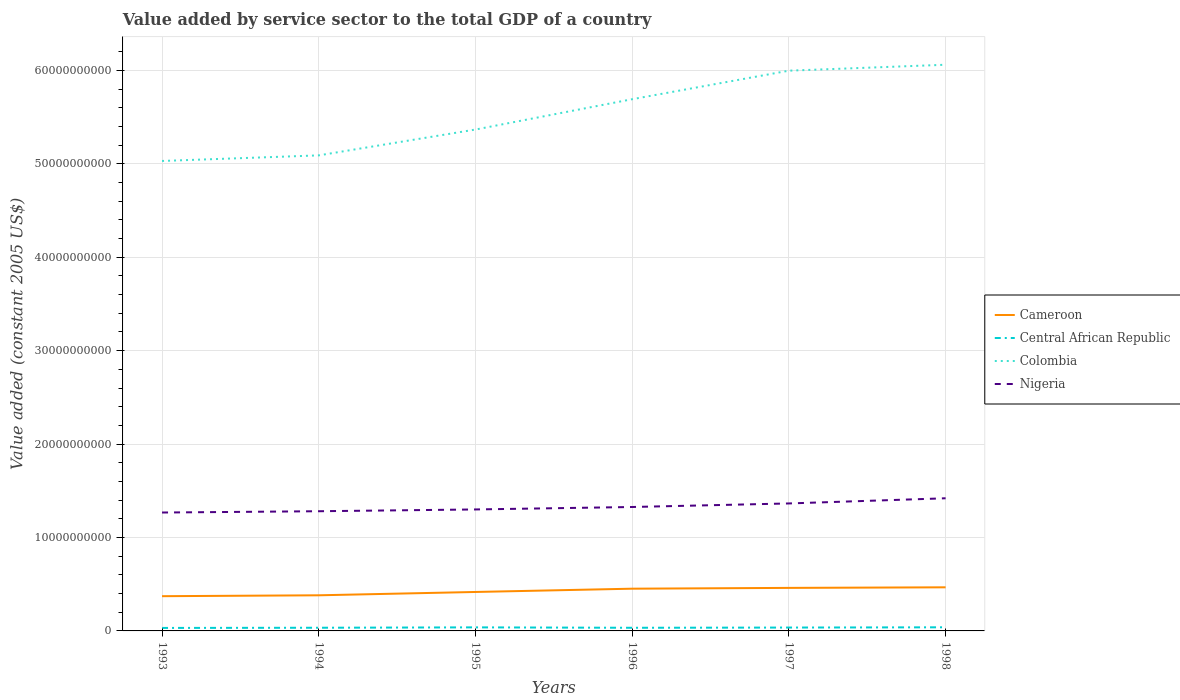How many different coloured lines are there?
Your answer should be compact. 4. Does the line corresponding to Nigeria intersect with the line corresponding to Colombia?
Provide a short and direct response. No. Across all years, what is the maximum value added by service sector in Cameroon?
Offer a terse response. 3.72e+09. In which year was the value added by service sector in Central African Republic maximum?
Make the answer very short. 1993. What is the total value added by service sector in Central African Republic in the graph?
Give a very brief answer. -4.06e+07. What is the difference between the highest and the second highest value added by service sector in Cameroon?
Make the answer very short. 9.51e+08. What is the difference between the highest and the lowest value added by service sector in Cameroon?
Your response must be concise. 3. Is the value added by service sector in Central African Republic strictly greater than the value added by service sector in Colombia over the years?
Your answer should be compact. Yes. How many lines are there?
Offer a terse response. 4. Does the graph contain any zero values?
Offer a very short reply. No. Where does the legend appear in the graph?
Your answer should be very brief. Center right. How are the legend labels stacked?
Offer a very short reply. Vertical. What is the title of the graph?
Your answer should be very brief. Value added by service sector to the total GDP of a country. What is the label or title of the X-axis?
Make the answer very short. Years. What is the label or title of the Y-axis?
Make the answer very short. Value added (constant 2005 US$). What is the Value added (constant 2005 US$) of Cameroon in 1993?
Your response must be concise. 3.72e+09. What is the Value added (constant 2005 US$) in Central African Republic in 1993?
Make the answer very short. 3.20e+08. What is the Value added (constant 2005 US$) in Colombia in 1993?
Provide a succinct answer. 5.03e+1. What is the Value added (constant 2005 US$) in Nigeria in 1993?
Give a very brief answer. 1.27e+1. What is the Value added (constant 2005 US$) of Cameroon in 1994?
Your answer should be compact. 3.81e+09. What is the Value added (constant 2005 US$) of Central African Republic in 1994?
Give a very brief answer. 3.40e+08. What is the Value added (constant 2005 US$) in Colombia in 1994?
Offer a terse response. 5.09e+1. What is the Value added (constant 2005 US$) of Nigeria in 1994?
Your answer should be very brief. 1.28e+1. What is the Value added (constant 2005 US$) in Cameroon in 1995?
Your response must be concise. 4.17e+09. What is the Value added (constant 2005 US$) in Central African Republic in 1995?
Offer a very short reply. 3.81e+08. What is the Value added (constant 2005 US$) in Colombia in 1995?
Ensure brevity in your answer.  5.37e+1. What is the Value added (constant 2005 US$) in Nigeria in 1995?
Offer a terse response. 1.30e+1. What is the Value added (constant 2005 US$) of Cameroon in 1996?
Offer a very short reply. 4.52e+09. What is the Value added (constant 2005 US$) in Central African Republic in 1996?
Give a very brief answer. 3.36e+08. What is the Value added (constant 2005 US$) of Colombia in 1996?
Keep it short and to the point. 5.69e+1. What is the Value added (constant 2005 US$) of Nigeria in 1996?
Offer a very short reply. 1.33e+1. What is the Value added (constant 2005 US$) of Cameroon in 1997?
Provide a short and direct response. 4.61e+09. What is the Value added (constant 2005 US$) in Central African Republic in 1997?
Offer a terse response. 3.60e+08. What is the Value added (constant 2005 US$) in Colombia in 1997?
Keep it short and to the point. 6.00e+1. What is the Value added (constant 2005 US$) in Nigeria in 1997?
Offer a terse response. 1.36e+1. What is the Value added (constant 2005 US$) of Cameroon in 1998?
Keep it short and to the point. 4.67e+09. What is the Value added (constant 2005 US$) in Central African Republic in 1998?
Provide a succinct answer. 3.87e+08. What is the Value added (constant 2005 US$) of Colombia in 1998?
Make the answer very short. 6.06e+1. What is the Value added (constant 2005 US$) in Nigeria in 1998?
Your response must be concise. 1.42e+1. Across all years, what is the maximum Value added (constant 2005 US$) of Cameroon?
Make the answer very short. 4.67e+09. Across all years, what is the maximum Value added (constant 2005 US$) of Central African Republic?
Offer a terse response. 3.87e+08. Across all years, what is the maximum Value added (constant 2005 US$) in Colombia?
Your answer should be very brief. 6.06e+1. Across all years, what is the maximum Value added (constant 2005 US$) in Nigeria?
Give a very brief answer. 1.42e+1. Across all years, what is the minimum Value added (constant 2005 US$) in Cameroon?
Your answer should be very brief. 3.72e+09. Across all years, what is the minimum Value added (constant 2005 US$) of Central African Republic?
Your answer should be compact. 3.20e+08. Across all years, what is the minimum Value added (constant 2005 US$) in Colombia?
Your answer should be very brief. 5.03e+1. Across all years, what is the minimum Value added (constant 2005 US$) in Nigeria?
Make the answer very short. 1.27e+1. What is the total Value added (constant 2005 US$) in Cameroon in the graph?
Offer a very short reply. 2.55e+1. What is the total Value added (constant 2005 US$) of Central African Republic in the graph?
Offer a very short reply. 2.12e+09. What is the total Value added (constant 2005 US$) in Colombia in the graph?
Your response must be concise. 3.32e+11. What is the total Value added (constant 2005 US$) in Nigeria in the graph?
Make the answer very short. 7.96e+1. What is the difference between the Value added (constant 2005 US$) of Cameroon in 1993 and that in 1994?
Ensure brevity in your answer.  -9.64e+07. What is the difference between the Value added (constant 2005 US$) in Central African Republic in 1993 and that in 1994?
Offer a terse response. -2.01e+07. What is the difference between the Value added (constant 2005 US$) in Colombia in 1993 and that in 1994?
Ensure brevity in your answer.  -5.99e+08. What is the difference between the Value added (constant 2005 US$) of Nigeria in 1993 and that in 1994?
Ensure brevity in your answer.  -1.39e+08. What is the difference between the Value added (constant 2005 US$) of Cameroon in 1993 and that in 1995?
Provide a succinct answer. -4.52e+08. What is the difference between the Value added (constant 2005 US$) of Central African Republic in 1993 and that in 1995?
Your answer should be compact. -6.07e+07. What is the difference between the Value added (constant 2005 US$) in Colombia in 1993 and that in 1995?
Provide a succinct answer. -3.36e+09. What is the difference between the Value added (constant 2005 US$) of Nigeria in 1993 and that in 1995?
Make the answer very short. -3.29e+08. What is the difference between the Value added (constant 2005 US$) in Cameroon in 1993 and that in 1996?
Your response must be concise. -8.04e+08. What is the difference between the Value added (constant 2005 US$) in Central African Republic in 1993 and that in 1996?
Provide a succinct answer. -1.63e+07. What is the difference between the Value added (constant 2005 US$) in Colombia in 1993 and that in 1996?
Your answer should be very brief. -6.61e+09. What is the difference between the Value added (constant 2005 US$) of Nigeria in 1993 and that in 1996?
Your answer should be very brief. -5.92e+08. What is the difference between the Value added (constant 2005 US$) of Cameroon in 1993 and that in 1997?
Provide a succinct answer. -8.88e+08. What is the difference between the Value added (constant 2005 US$) in Central African Republic in 1993 and that in 1997?
Provide a succinct answer. -4.06e+07. What is the difference between the Value added (constant 2005 US$) of Colombia in 1993 and that in 1997?
Offer a terse response. -9.66e+09. What is the difference between the Value added (constant 2005 US$) in Nigeria in 1993 and that in 1997?
Ensure brevity in your answer.  -9.72e+08. What is the difference between the Value added (constant 2005 US$) of Cameroon in 1993 and that in 1998?
Your answer should be compact. -9.51e+08. What is the difference between the Value added (constant 2005 US$) of Central African Republic in 1993 and that in 1998?
Offer a terse response. -6.74e+07. What is the difference between the Value added (constant 2005 US$) of Colombia in 1993 and that in 1998?
Offer a terse response. -1.03e+1. What is the difference between the Value added (constant 2005 US$) in Nigeria in 1993 and that in 1998?
Your answer should be very brief. -1.53e+09. What is the difference between the Value added (constant 2005 US$) in Cameroon in 1994 and that in 1995?
Offer a terse response. -3.55e+08. What is the difference between the Value added (constant 2005 US$) of Central African Republic in 1994 and that in 1995?
Give a very brief answer. -4.06e+07. What is the difference between the Value added (constant 2005 US$) of Colombia in 1994 and that in 1995?
Your response must be concise. -2.77e+09. What is the difference between the Value added (constant 2005 US$) of Nigeria in 1994 and that in 1995?
Provide a succinct answer. -1.90e+08. What is the difference between the Value added (constant 2005 US$) of Cameroon in 1994 and that in 1996?
Your answer should be compact. -7.07e+08. What is the difference between the Value added (constant 2005 US$) in Central African Republic in 1994 and that in 1996?
Your answer should be compact. 3.79e+06. What is the difference between the Value added (constant 2005 US$) in Colombia in 1994 and that in 1996?
Keep it short and to the point. -6.01e+09. What is the difference between the Value added (constant 2005 US$) in Nigeria in 1994 and that in 1996?
Offer a very short reply. -4.53e+08. What is the difference between the Value added (constant 2005 US$) in Cameroon in 1994 and that in 1997?
Ensure brevity in your answer.  -7.92e+08. What is the difference between the Value added (constant 2005 US$) in Central African Republic in 1994 and that in 1997?
Your answer should be compact. -2.05e+07. What is the difference between the Value added (constant 2005 US$) of Colombia in 1994 and that in 1997?
Offer a very short reply. -9.07e+09. What is the difference between the Value added (constant 2005 US$) in Nigeria in 1994 and that in 1997?
Provide a succinct answer. -8.33e+08. What is the difference between the Value added (constant 2005 US$) in Cameroon in 1994 and that in 1998?
Make the answer very short. -8.55e+08. What is the difference between the Value added (constant 2005 US$) in Central African Republic in 1994 and that in 1998?
Your answer should be compact. -4.73e+07. What is the difference between the Value added (constant 2005 US$) in Colombia in 1994 and that in 1998?
Give a very brief answer. -9.70e+09. What is the difference between the Value added (constant 2005 US$) in Nigeria in 1994 and that in 1998?
Provide a succinct answer. -1.39e+09. What is the difference between the Value added (constant 2005 US$) in Cameroon in 1995 and that in 1996?
Give a very brief answer. -3.52e+08. What is the difference between the Value added (constant 2005 US$) of Central African Republic in 1995 and that in 1996?
Offer a terse response. 4.44e+07. What is the difference between the Value added (constant 2005 US$) in Colombia in 1995 and that in 1996?
Offer a terse response. -3.25e+09. What is the difference between the Value added (constant 2005 US$) of Nigeria in 1995 and that in 1996?
Keep it short and to the point. -2.63e+08. What is the difference between the Value added (constant 2005 US$) of Cameroon in 1995 and that in 1997?
Provide a succinct answer. -4.36e+08. What is the difference between the Value added (constant 2005 US$) of Central African Republic in 1995 and that in 1997?
Offer a terse response. 2.01e+07. What is the difference between the Value added (constant 2005 US$) of Colombia in 1995 and that in 1997?
Provide a succinct answer. -6.30e+09. What is the difference between the Value added (constant 2005 US$) of Nigeria in 1995 and that in 1997?
Offer a terse response. -6.43e+08. What is the difference between the Value added (constant 2005 US$) of Cameroon in 1995 and that in 1998?
Offer a very short reply. -5.00e+08. What is the difference between the Value added (constant 2005 US$) in Central African Republic in 1995 and that in 1998?
Ensure brevity in your answer.  -6.71e+06. What is the difference between the Value added (constant 2005 US$) of Colombia in 1995 and that in 1998?
Offer a terse response. -6.94e+09. What is the difference between the Value added (constant 2005 US$) in Nigeria in 1995 and that in 1998?
Make the answer very short. -1.20e+09. What is the difference between the Value added (constant 2005 US$) in Cameroon in 1996 and that in 1997?
Keep it short and to the point. -8.45e+07. What is the difference between the Value added (constant 2005 US$) in Central African Republic in 1996 and that in 1997?
Provide a short and direct response. -2.43e+07. What is the difference between the Value added (constant 2005 US$) in Colombia in 1996 and that in 1997?
Make the answer very short. -3.05e+09. What is the difference between the Value added (constant 2005 US$) in Nigeria in 1996 and that in 1997?
Provide a succinct answer. -3.80e+08. What is the difference between the Value added (constant 2005 US$) in Cameroon in 1996 and that in 1998?
Keep it short and to the point. -1.48e+08. What is the difference between the Value added (constant 2005 US$) of Central African Republic in 1996 and that in 1998?
Offer a very short reply. -5.11e+07. What is the difference between the Value added (constant 2005 US$) of Colombia in 1996 and that in 1998?
Your answer should be very brief. -3.69e+09. What is the difference between the Value added (constant 2005 US$) in Nigeria in 1996 and that in 1998?
Keep it short and to the point. -9.34e+08. What is the difference between the Value added (constant 2005 US$) of Cameroon in 1997 and that in 1998?
Make the answer very short. -6.31e+07. What is the difference between the Value added (constant 2005 US$) of Central African Republic in 1997 and that in 1998?
Provide a short and direct response. -2.68e+07. What is the difference between the Value added (constant 2005 US$) in Colombia in 1997 and that in 1998?
Give a very brief answer. -6.36e+08. What is the difference between the Value added (constant 2005 US$) in Nigeria in 1997 and that in 1998?
Your answer should be very brief. -5.54e+08. What is the difference between the Value added (constant 2005 US$) in Cameroon in 1993 and the Value added (constant 2005 US$) in Central African Republic in 1994?
Keep it short and to the point. 3.38e+09. What is the difference between the Value added (constant 2005 US$) in Cameroon in 1993 and the Value added (constant 2005 US$) in Colombia in 1994?
Offer a terse response. -4.72e+1. What is the difference between the Value added (constant 2005 US$) in Cameroon in 1993 and the Value added (constant 2005 US$) in Nigeria in 1994?
Your answer should be very brief. -9.09e+09. What is the difference between the Value added (constant 2005 US$) of Central African Republic in 1993 and the Value added (constant 2005 US$) of Colombia in 1994?
Provide a short and direct response. -5.06e+1. What is the difference between the Value added (constant 2005 US$) in Central African Republic in 1993 and the Value added (constant 2005 US$) in Nigeria in 1994?
Your response must be concise. -1.25e+1. What is the difference between the Value added (constant 2005 US$) in Colombia in 1993 and the Value added (constant 2005 US$) in Nigeria in 1994?
Offer a terse response. 3.75e+1. What is the difference between the Value added (constant 2005 US$) in Cameroon in 1993 and the Value added (constant 2005 US$) in Central African Republic in 1995?
Your response must be concise. 3.34e+09. What is the difference between the Value added (constant 2005 US$) of Cameroon in 1993 and the Value added (constant 2005 US$) of Colombia in 1995?
Offer a terse response. -5.00e+1. What is the difference between the Value added (constant 2005 US$) in Cameroon in 1993 and the Value added (constant 2005 US$) in Nigeria in 1995?
Make the answer very short. -9.28e+09. What is the difference between the Value added (constant 2005 US$) in Central African Republic in 1993 and the Value added (constant 2005 US$) in Colombia in 1995?
Your answer should be compact. -5.33e+1. What is the difference between the Value added (constant 2005 US$) of Central African Republic in 1993 and the Value added (constant 2005 US$) of Nigeria in 1995?
Your response must be concise. -1.27e+1. What is the difference between the Value added (constant 2005 US$) in Colombia in 1993 and the Value added (constant 2005 US$) in Nigeria in 1995?
Keep it short and to the point. 3.73e+1. What is the difference between the Value added (constant 2005 US$) of Cameroon in 1993 and the Value added (constant 2005 US$) of Central African Republic in 1996?
Your answer should be very brief. 3.38e+09. What is the difference between the Value added (constant 2005 US$) of Cameroon in 1993 and the Value added (constant 2005 US$) of Colombia in 1996?
Offer a terse response. -5.32e+1. What is the difference between the Value added (constant 2005 US$) in Cameroon in 1993 and the Value added (constant 2005 US$) in Nigeria in 1996?
Make the answer very short. -9.55e+09. What is the difference between the Value added (constant 2005 US$) of Central African Republic in 1993 and the Value added (constant 2005 US$) of Colombia in 1996?
Keep it short and to the point. -5.66e+1. What is the difference between the Value added (constant 2005 US$) of Central African Republic in 1993 and the Value added (constant 2005 US$) of Nigeria in 1996?
Keep it short and to the point. -1.29e+1. What is the difference between the Value added (constant 2005 US$) of Colombia in 1993 and the Value added (constant 2005 US$) of Nigeria in 1996?
Your answer should be compact. 3.70e+1. What is the difference between the Value added (constant 2005 US$) in Cameroon in 1993 and the Value added (constant 2005 US$) in Central African Republic in 1997?
Give a very brief answer. 3.36e+09. What is the difference between the Value added (constant 2005 US$) of Cameroon in 1993 and the Value added (constant 2005 US$) of Colombia in 1997?
Your response must be concise. -5.63e+1. What is the difference between the Value added (constant 2005 US$) in Cameroon in 1993 and the Value added (constant 2005 US$) in Nigeria in 1997?
Your answer should be compact. -9.93e+09. What is the difference between the Value added (constant 2005 US$) of Central African Republic in 1993 and the Value added (constant 2005 US$) of Colombia in 1997?
Offer a very short reply. -5.96e+1. What is the difference between the Value added (constant 2005 US$) of Central African Republic in 1993 and the Value added (constant 2005 US$) of Nigeria in 1997?
Keep it short and to the point. -1.33e+1. What is the difference between the Value added (constant 2005 US$) in Colombia in 1993 and the Value added (constant 2005 US$) in Nigeria in 1997?
Keep it short and to the point. 3.67e+1. What is the difference between the Value added (constant 2005 US$) of Cameroon in 1993 and the Value added (constant 2005 US$) of Central African Republic in 1998?
Offer a very short reply. 3.33e+09. What is the difference between the Value added (constant 2005 US$) of Cameroon in 1993 and the Value added (constant 2005 US$) of Colombia in 1998?
Make the answer very short. -5.69e+1. What is the difference between the Value added (constant 2005 US$) in Cameroon in 1993 and the Value added (constant 2005 US$) in Nigeria in 1998?
Give a very brief answer. -1.05e+1. What is the difference between the Value added (constant 2005 US$) in Central African Republic in 1993 and the Value added (constant 2005 US$) in Colombia in 1998?
Your answer should be compact. -6.03e+1. What is the difference between the Value added (constant 2005 US$) of Central African Republic in 1993 and the Value added (constant 2005 US$) of Nigeria in 1998?
Your answer should be compact. -1.39e+1. What is the difference between the Value added (constant 2005 US$) in Colombia in 1993 and the Value added (constant 2005 US$) in Nigeria in 1998?
Your response must be concise. 3.61e+1. What is the difference between the Value added (constant 2005 US$) of Cameroon in 1994 and the Value added (constant 2005 US$) of Central African Republic in 1995?
Give a very brief answer. 3.43e+09. What is the difference between the Value added (constant 2005 US$) in Cameroon in 1994 and the Value added (constant 2005 US$) in Colombia in 1995?
Keep it short and to the point. -4.99e+1. What is the difference between the Value added (constant 2005 US$) in Cameroon in 1994 and the Value added (constant 2005 US$) in Nigeria in 1995?
Give a very brief answer. -9.19e+09. What is the difference between the Value added (constant 2005 US$) in Central African Republic in 1994 and the Value added (constant 2005 US$) in Colombia in 1995?
Ensure brevity in your answer.  -5.33e+1. What is the difference between the Value added (constant 2005 US$) of Central African Republic in 1994 and the Value added (constant 2005 US$) of Nigeria in 1995?
Offer a terse response. -1.27e+1. What is the difference between the Value added (constant 2005 US$) of Colombia in 1994 and the Value added (constant 2005 US$) of Nigeria in 1995?
Your answer should be compact. 3.79e+1. What is the difference between the Value added (constant 2005 US$) of Cameroon in 1994 and the Value added (constant 2005 US$) of Central African Republic in 1996?
Make the answer very short. 3.48e+09. What is the difference between the Value added (constant 2005 US$) in Cameroon in 1994 and the Value added (constant 2005 US$) in Colombia in 1996?
Ensure brevity in your answer.  -5.31e+1. What is the difference between the Value added (constant 2005 US$) in Cameroon in 1994 and the Value added (constant 2005 US$) in Nigeria in 1996?
Provide a succinct answer. -9.45e+09. What is the difference between the Value added (constant 2005 US$) in Central African Republic in 1994 and the Value added (constant 2005 US$) in Colombia in 1996?
Make the answer very short. -5.66e+1. What is the difference between the Value added (constant 2005 US$) in Central African Republic in 1994 and the Value added (constant 2005 US$) in Nigeria in 1996?
Provide a short and direct response. -1.29e+1. What is the difference between the Value added (constant 2005 US$) in Colombia in 1994 and the Value added (constant 2005 US$) in Nigeria in 1996?
Ensure brevity in your answer.  3.76e+1. What is the difference between the Value added (constant 2005 US$) of Cameroon in 1994 and the Value added (constant 2005 US$) of Central African Republic in 1997?
Offer a terse response. 3.45e+09. What is the difference between the Value added (constant 2005 US$) of Cameroon in 1994 and the Value added (constant 2005 US$) of Colombia in 1997?
Make the answer very short. -5.62e+1. What is the difference between the Value added (constant 2005 US$) in Cameroon in 1994 and the Value added (constant 2005 US$) in Nigeria in 1997?
Provide a succinct answer. -9.83e+09. What is the difference between the Value added (constant 2005 US$) in Central African Republic in 1994 and the Value added (constant 2005 US$) in Colombia in 1997?
Offer a terse response. -5.96e+1. What is the difference between the Value added (constant 2005 US$) of Central African Republic in 1994 and the Value added (constant 2005 US$) of Nigeria in 1997?
Offer a very short reply. -1.33e+1. What is the difference between the Value added (constant 2005 US$) of Colombia in 1994 and the Value added (constant 2005 US$) of Nigeria in 1997?
Keep it short and to the point. 3.73e+1. What is the difference between the Value added (constant 2005 US$) in Cameroon in 1994 and the Value added (constant 2005 US$) in Central African Republic in 1998?
Offer a very short reply. 3.43e+09. What is the difference between the Value added (constant 2005 US$) of Cameroon in 1994 and the Value added (constant 2005 US$) of Colombia in 1998?
Provide a succinct answer. -5.68e+1. What is the difference between the Value added (constant 2005 US$) of Cameroon in 1994 and the Value added (constant 2005 US$) of Nigeria in 1998?
Provide a succinct answer. -1.04e+1. What is the difference between the Value added (constant 2005 US$) in Central African Republic in 1994 and the Value added (constant 2005 US$) in Colombia in 1998?
Provide a succinct answer. -6.03e+1. What is the difference between the Value added (constant 2005 US$) of Central African Republic in 1994 and the Value added (constant 2005 US$) of Nigeria in 1998?
Provide a succinct answer. -1.39e+1. What is the difference between the Value added (constant 2005 US$) in Colombia in 1994 and the Value added (constant 2005 US$) in Nigeria in 1998?
Provide a short and direct response. 3.67e+1. What is the difference between the Value added (constant 2005 US$) of Cameroon in 1995 and the Value added (constant 2005 US$) of Central African Republic in 1996?
Ensure brevity in your answer.  3.83e+09. What is the difference between the Value added (constant 2005 US$) of Cameroon in 1995 and the Value added (constant 2005 US$) of Colombia in 1996?
Ensure brevity in your answer.  -5.27e+1. What is the difference between the Value added (constant 2005 US$) of Cameroon in 1995 and the Value added (constant 2005 US$) of Nigeria in 1996?
Your response must be concise. -9.10e+09. What is the difference between the Value added (constant 2005 US$) in Central African Republic in 1995 and the Value added (constant 2005 US$) in Colombia in 1996?
Your answer should be compact. -5.65e+1. What is the difference between the Value added (constant 2005 US$) of Central African Republic in 1995 and the Value added (constant 2005 US$) of Nigeria in 1996?
Provide a short and direct response. -1.29e+1. What is the difference between the Value added (constant 2005 US$) in Colombia in 1995 and the Value added (constant 2005 US$) in Nigeria in 1996?
Give a very brief answer. 4.04e+1. What is the difference between the Value added (constant 2005 US$) of Cameroon in 1995 and the Value added (constant 2005 US$) of Central African Republic in 1997?
Offer a terse response. 3.81e+09. What is the difference between the Value added (constant 2005 US$) in Cameroon in 1995 and the Value added (constant 2005 US$) in Colombia in 1997?
Ensure brevity in your answer.  -5.58e+1. What is the difference between the Value added (constant 2005 US$) of Cameroon in 1995 and the Value added (constant 2005 US$) of Nigeria in 1997?
Keep it short and to the point. -9.48e+09. What is the difference between the Value added (constant 2005 US$) in Central African Republic in 1995 and the Value added (constant 2005 US$) in Colombia in 1997?
Give a very brief answer. -5.96e+1. What is the difference between the Value added (constant 2005 US$) of Central African Republic in 1995 and the Value added (constant 2005 US$) of Nigeria in 1997?
Keep it short and to the point. -1.33e+1. What is the difference between the Value added (constant 2005 US$) of Colombia in 1995 and the Value added (constant 2005 US$) of Nigeria in 1997?
Offer a terse response. 4.00e+1. What is the difference between the Value added (constant 2005 US$) in Cameroon in 1995 and the Value added (constant 2005 US$) in Central African Republic in 1998?
Your answer should be compact. 3.78e+09. What is the difference between the Value added (constant 2005 US$) of Cameroon in 1995 and the Value added (constant 2005 US$) of Colombia in 1998?
Your answer should be compact. -5.64e+1. What is the difference between the Value added (constant 2005 US$) in Cameroon in 1995 and the Value added (constant 2005 US$) in Nigeria in 1998?
Offer a terse response. -1.00e+1. What is the difference between the Value added (constant 2005 US$) of Central African Republic in 1995 and the Value added (constant 2005 US$) of Colombia in 1998?
Your answer should be compact. -6.02e+1. What is the difference between the Value added (constant 2005 US$) in Central African Republic in 1995 and the Value added (constant 2005 US$) in Nigeria in 1998?
Ensure brevity in your answer.  -1.38e+1. What is the difference between the Value added (constant 2005 US$) in Colombia in 1995 and the Value added (constant 2005 US$) in Nigeria in 1998?
Ensure brevity in your answer.  3.95e+1. What is the difference between the Value added (constant 2005 US$) of Cameroon in 1996 and the Value added (constant 2005 US$) of Central African Republic in 1997?
Offer a terse response. 4.16e+09. What is the difference between the Value added (constant 2005 US$) in Cameroon in 1996 and the Value added (constant 2005 US$) in Colombia in 1997?
Make the answer very short. -5.54e+1. What is the difference between the Value added (constant 2005 US$) in Cameroon in 1996 and the Value added (constant 2005 US$) in Nigeria in 1997?
Make the answer very short. -9.12e+09. What is the difference between the Value added (constant 2005 US$) of Central African Republic in 1996 and the Value added (constant 2005 US$) of Colombia in 1997?
Your response must be concise. -5.96e+1. What is the difference between the Value added (constant 2005 US$) in Central African Republic in 1996 and the Value added (constant 2005 US$) in Nigeria in 1997?
Your answer should be very brief. -1.33e+1. What is the difference between the Value added (constant 2005 US$) of Colombia in 1996 and the Value added (constant 2005 US$) of Nigeria in 1997?
Provide a short and direct response. 4.33e+1. What is the difference between the Value added (constant 2005 US$) of Cameroon in 1996 and the Value added (constant 2005 US$) of Central African Republic in 1998?
Make the answer very short. 4.13e+09. What is the difference between the Value added (constant 2005 US$) in Cameroon in 1996 and the Value added (constant 2005 US$) in Colombia in 1998?
Keep it short and to the point. -5.61e+1. What is the difference between the Value added (constant 2005 US$) in Cameroon in 1996 and the Value added (constant 2005 US$) in Nigeria in 1998?
Provide a short and direct response. -9.68e+09. What is the difference between the Value added (constant 2005 US$) in Central African Republic in 1996 and the Value added (constant 2005 US$) in Colombia in 1998?
Offer a terse response. -6.03e+1. What is the difference between the Value added (constant 2005 US$) of Central African Republic in 1996 and the Value added (constant 2005 US$) of Nigeria in 1998?
Offer a very short reply. -1.39e+1. What is the difference between the Value added (constant 2005 US$) in Colombia in 1996 and the Value added (constant 2005 US$) in Nigeria in 1998?
Your answer should be very brief. 4.27e+1. What is the difference between the Value added (constant 2005 US$) in Cameroon in 1997 and the Value added (constant 2005 US$) in Central African Republic in 1998?
Your answer should be very brief. 4.22e+09. What is the difference between the Value added (constant 2005 US$) in Cameroon in 1997 and the Value added (constant 2005 US$) in Colombia in 1998?
Your answer should be compact. -5.60e+1. What is the difference between the Value added (constant 2005 US$) in Cameroon in 1997 and the Value added (constant 2005 US$) in Nigeria in 1998?
Keep it short and to the point. -9.59e+09. What is the difference between the Value added (constant 2005 US$) in Central African Republic in 1997 and the Value added (constant 2005 US$) in Colombia in 1998?
Your answer should be compact. -6.02e+1. What is the difference between the Value added (constant 2005 US$) of Central African Republic in 1997 and the Value added (constant 2005 US$) of Nigeria in 1998?
Offer a very short reply. -1.38e+1. What is the difference between the Value added (constant 2005 US$) of Colombia in 1997 and the Value added (constant 2005 US$) of Nigeria in 1998?
Give a very brief answer. 4.58e+1. What is the average Value added (constant 2005 US$) in Cameroon per year?
Offer a very short reply. 4.25e+09. What is the average Value added (constant 2005 US$) of Central African Republic per year?
Offer a terse response. 3.54e+08. What is the average Value added (constant 2005 US$) in Colombia per year?
Ensure brevity in your answer.  5.54e+1. What is the average Value added (constant 2005 US$) of Nigeria per year?
Provide a short and direct response. 1.33e+1. In the year 1993, what is the difference between the Value added (constant 2005 US$) in Cameroon and Value added (constant 2005 US$) in Central African Republic?
Keep it short and to the point. 3.40e+09. In the year 1993, what is the difference between the Value added (constant 2005 US$) of Cameroon and Value added (constant 2005 US$) of Colombia?
Give a very brief answer. -4.66e+1. In the year 1993, what is the difference between the Value added (constant 2005 US$) of Cameroon and Value added (constant 2005 US$) of Nigeria?
Offer a terse response. -8.96e+09. In the year 1993, what is the difference between the Value added (constant 2005 US$) of Central African Republic and Value added (constant 2005 US$) of Colombia?
Provide a succinct answer. -5.00e+1. In the year 1993, what is the difference between the Value added (constant 2005 US$) of Central African Republic and Value added (constant 2005 US$) of Nigeria?
Ensure brevity in your answer.  -1.24e+1. In the year 1993, what is the difference between the Value added (constant 2005 US$) in Colombia and Value added (constant 2005 US$) in Nigeria?
Provide a succinct answer. 3.76e+1. In the year 1994, what is the difference between the Value added (constant 2005 US$) in Cameroon and Value added (constant 2005 US$) in Central African Republic?
Make the answer very short. 3.47e+09. In the year 1994, what is the difference between the Value added (constant 2005 US$) of Cameroon and Value added (constant 2005 US$) of Colombia?
Offer a very short reply. -4.71e+1. In the year 1994, what is the difference between the Value added (constant 2005 US$) in Cameroon and Value added (constant 2005 US$) in Nigeria?
Keep it short and to the point. -9.00e+09. In the year 1994, what is the difference between the Value added (constant 2005 US$) in Central African Republic and Value added (constant 2005 US$) in Colombia?
Your answer should be very brief. -5.06e+1. In the year 1994, what is the difference between the Value added (constant 2005 US$) in Central African Republic and Value added (constant 2005 US$) in Nigeria?
Your response must be concise. -1.25e+1. In the year 1994, what is the difference between the Value added (constant 2005 US$) in Colombia and Value added (constant 2005 US$) in Nigeria?
Keep it short and to the point. 3.81e+1. In the year 1995, what is the difference between the Value added (constant 2005 US$) of Cameroon and Value added (constant 2005 US$) of Central African Republic?
Offer a terse response. 3.79e+09. In the year 1995, what is the difference between the Value added (constant 2005 US$) in Cameroon and Value added (constant 2005 US$) in Colombia?
Offer a very short reply. -4.95e+1. In the year 1995, what is the difference between the Value added (constant 2005 US$) of Cameroon and Value added (constant 2005 US$) of Nigeria?
Ensure brevity in your answer.  -8.83e+09. In the year 1995, what is the difference between the Value added (constant 2005 US$) of Central African Republic and Value added (constant 2005 US$) of Colombia?
Your answer should be compact. -5.33e+1. In the year 1995, what is the difference between the Value added (constant 2005 US$) of Central African Republic and Value added (constant 2005 US$) of Nigeria?
Provide a succinct answer. -1.26e+1. In the year 1995, what is the difference between the Value added (constant 2005 US$) in Colombia and Value added (constant 2005 US$) in Nigeria?
Ensure brevity in your answer.  4.07e+1. In the year 1996, what is the difference between the Value added (constant 2005 US$) of Cameroon and Value added (constant 2005 US$) of Central African Republic?
Your answer should be compact. 4.18e+09. In the year 1996, what is the difference between the Value added (constant 2005 US$) of Cameroon and Value added (constant 2005 US$) of Colombia?
Your answer should be compact. -5.24e+1. In the year 1996, what is the difference between the Value added (constant 2005 US$) of Cameroon and Value added (constant 2005 US$) of Nigeria?
Offer a very short reply. -8.74e+09. In the year 1996, what is the difference between the Value added (constant 2005 US$) of Central African Republic and Value added (constant 2005 US$) of Colombia?
Your response must be concise. -5.66e+1. In the year 1996, what is the difference between the Value added (constant 2005 US$) in Central African Republic and Value added (constant 2005 US$) in Nigeria?
Offer a very short reply. -1.29e+1. In the year 1996, what is the difference between the Value added (constant 2005 US$) of Colombia and Value added (constant 2005 US$) of Nigeria?
Offer a very short reply. 4.37e+1. In the year 1997, what is the difference between the Value added (constant 2005 US$) in Cameroon and Value added (constant 2005 US$) in Central African Republic?
Ensure brevity in your answer.  4.25e+09. In the year 1997, what is the difference between the Value added (constant 2005 US$) in Cameroon and Value added (constant 2005 US$) in Colombia?
Provide a short and direct response. -5.54e+1. In the year 1997, what is the difference between the Value added (constant 2005 US$) in Cameroon and Value added (constant 2005 US$) in Nigeria?
Offer a very short reply. -9.04e+09. In the year 1997, what is the difference between the Value added (constant 2005 US$) in Central African Republic and Value added (constant 2005 US$) in Colombia?
Your response must be concise. -5.96e+1. In the year 1997, what is the difference between the Value added (constant 2005 US$) in Central African Republic and Value added (constant 2005 US$) in Nigeria?
Ensure brevity in your answer.  -1.33e+1. In the year 1997, what is the difference between the Value added (constant 2005 US$) in Colombia and Value added (constant 2005 US$) in Nigeria?
Offer a very short reply. 4.63e+1. In the year 1998, what is the difference between the Value added (constant 2005 US$) of Cameroon and Value added (constant 2005 US$) of Central African Republic?
Your answer should be very brief. 4.28e+09. In the year 1998, what is the difference between the Value added (constant 2005 US$) of Cameroon and Value added (constant 2005 US$) of Colombia?
Make the answer very short. -5.59e+1. In the year 1998, what is the difference between the Value added (constant 2005 US$) of Cameroon and Value added (constant 2005 US$) of Nigeria?
Give a very brief answer. -9.53e+09. In the year 1998, what is the difference between the Value added (constant 2005 US$) in Central African Republic and Value added (constant 2005 US$) in Colombia?
Ensure brevity in your answer.  -6.02e+1. In the year 1998, what is the difference between the Value added (constant 2005 US$) of Central African Republic and Value added (constant 2005 US$) of Nigeria?
Give a very brief answer. -1.38e+1. In the year 1998, what is the difference between the Value added (constant 2005 US$) of Colombia and Value added (constant 2005 US$) of Nigeria?
Give a very brief answer. 4.64e+1. What is the ratio of the Value added (constant 2005 US$) in Cameroon in 1993 to that in 1994?
Keep it short and to the point. 0.97. What is the ratio of the Value added (constant 2005 US$) in Central African Republic in 1993 to that in 1994?
Provide a short and direct response. 0.94. What is the ratio of the Value added (constant 2005 US$) of Colombia in 1993 to that in 1994?
Keep it short and to the point. 0.99. What is the ratio of the Value added (constant 2005 US$) in Cameroon in 1993 to that in 1995?
Offer a terse response. 0.89. What is the ratio of the Value added (constant 2005 US$) of Central African Republic in 1993 to that in 1995?
Offer a terse response. 0.84. What is the ratio of the Value added (constant 2005 US$) of Colombia in 1993 to that in 1995?
Give a very brief answer. 0.94. What is the ratio of the Value added (constant 2005 US$) of Nigeria in 1993 to that in 1995?
Give a very brief answer. 0.97. What is the ratio of the Value added (constant 2005 US$) in Cameroon in 1993 to that in 1996?
Provide a succinct answer. 0.82. What is the ratio of the Value added (constant 2005 US$) in Central African Republic in 1993 to that in 1996?
Ensure brevity in your answer.  0.95. What is the ratio of the Value added (constant 2005 US$) in Colombia in 1993 to that in 1996?
Your response must be concise. 0.88. What is the ratio of the Value added (constant 2005 US$) in Nigeria in 1993 to that in 1996?
Your answer should be very brief. 0.96. What is the ratio of the Value added (constant 2005 US$) of Cameroon in 1993 to that in 1997?
Ensure brevity in your answer.  0.81. What is the ratio of the Value added (constant 2005 US$) in Central African Republic in 1993 to that in 1997?
Provide a short and direct response. 0.89. What is the ratio of the Value added (constant 2005 US$) of Colombia in 1993 to that in 1997?
Offer a very short reply. 0.84. What is the ratio of the Value added (constant 2005 US$) of Nigeria in 1993 to that in 1997?
Ensure brevity in your answer.  0.93. What is the ratio of the Value added (constant 2005 US$) in Cameroon in 1993 to that in 1998?
Keep it short and to the point. 0.8. What is the ratio of the Value added (constant 2005 US$) of Central African Republic in 1993 to that in 1998?
Provide a short and direct response. 0.83. What is the ratio of the Value added (constant 2005 US$) in Colombia in 1993 to that in 1998?
Your response must be concise. 0.83. What is the ratio of the Value added (constant 2005 US$) of Nigeria in 1993 to that in 1998?
Offer a terse response. 0.89. What is the ratio of the Value added (constant 2005 US$) in Cameroon in 1994 to that in 1995?
Provide a succinct answer. 0.91. What is the ratio of the Value added (constant 2005 US$) of Central African Republic in 1994 to that in 1995?
Offer a very short reply. 0.89. What is the ratio of the Value added (constant 2005 US$) of Colombia in 1994 to that in 1995?
Offer a very short reply. 0.95. What is the ratio of the Value added (constant 2005 US$) of Nigeria in 1994 to that in 1995?
Offer a terse response. 0.99. What is the ratio of the Value added (constant 2005 US$) in Cameroon in 1994 to that in 1996?
Ensure brevity in your answer.  0.84. What is the ratio of the Value added (constant 2005 US$) of Central African Republic in 1994 to that in 1996?
Make the answer very short. 1.01. What is the ratio of the Value added (constant 2005 US$) in Colombia in 1994 to that in 1996?
Give a very brief answer. 0.89. What is the ratio of the Value added (constant 2005 US$) of Nigeria in 1994 to that in 1996?
Offer a very short reply. 0.97. What is the ratio of the Value added (constant 2005 US$) of Cameroon in 1994 to that in 1997?
Ensure brevity in your answer.  0.83. What is the ratio of the Value added (constant 2005 US$) of Central African Republic in 1994 to that in 1997?
Ensure brevity in your answer.  0.94. What is the ratio of the Value added (constant 2005 US$) of Colombia in 1994 to that in 1997?
Give a very brief answer. 0.85. What is the ratio of the Value added (constant 2005 US$) in Nigeria in 1994 to that in 1997?
Your answer should be very brief. 0.94. What is the ratio of the Value added (constant 2005 US$) in Cameroon in 1994 to that in 1998?
Make the answer very short. 0.82. What is the ratio of the Value added (constant 2005 US$) of Central African Republic in 1994 to that in 1998?
Make the answer very short. 0.88. What is the ratio of the Value added (constant 2005 US$) in Colombia in 1994 to that in 1998?
Your answer should be compact. 0.84. What is the ratio of the Value added (constant 2005 US$) of Nigeria in 1994 to that in 1998?
Ensure brevity in your answer.  0.9. What is the ratio of the Value added (constant 2005 US$) of Cameroon in 1995 to that in 1996?
Offer a very short reply. 0.92. What is the ratio of the Value added (constant 2005 US$) in Central African Republic in 1995 to that in 1996?
Provide a short and direct response. 1.13. What is the ratio of the Value added (constant 2005 US$) of Colombia in 1995 to that in 1996?
Give a very brief answer. 0.94. What is the ratio of the Value added (constant 2005 US$) of Nigeria in 1995 to that in 1996?
Provide a short and direct response. 0.98. What is the ratio of the Value added (constant 2005 US$) of Cameroon in 1995 to that in 1997?
Your response must be concise. 0.91. What is the ratio of the Value added (constant 2005 US$) in Central African Republic in 1995 to that in 1997?
Provide a succinct answer. 1.06. What is the ratio of the Value added (constant 2005 US$) in Colombia in 1995 to that in 1997?
Offer a very short reply. 0.89. What is the ratio of the Value added (constant 2005 US$) in Nigeria in 1995 to that in 1997?
Your answer should be compact. 0.95. What is the ratio of the Value added (constant 2005 US$) in Cameroon in 1995 to that in 1998?
Provide a succinct answer. 0.89. What is the ratio of the Value added (constant 2005 US$) of Central African Republic in 1995 to that in 1998?
Keep it short and to the point. 0.98. What is the ratio of the Value added (constant 2005 US$) in Colombia in 1995 to that in 1998?
Give a very brief answer. 0.89. What is the ratio of the Value added (constant 2005 US$) of Nigeria in 1995 to that in 1998?
Give a very brief answer. 0.92. What is the ratio of the Value added (constant 2005 US$) of Cameroon in 1996 to that in 1997?
Make the answer very short. 0.98. What is the ratio of the Value added (constant 2005 US$) in Central African Republic in 1996 to that in 1997?
Provide a short and direct response. 0.93. What is the ratio of the Value added (constant 2005 US$) of Colombia in 1996 to that in 1997?
Your answer should be very brief. 0.95. What is the ratio of the Value added (constant 2005 US$) in Nigeria in 1996 to that in 1997?
Provide a short and direct response. 0.97. What is the ratio of the Value added (constant 2005 US$) of Cameroon in 1996 to that in 1998?
Keep it short and to the point. 0.97. What is the ratio of the Value added (constant 2005 US$) in Central African Republic in 1996 to that in 1998?
Keep it short and to the point. 0.87. What is the ratio of the Value added (constant 2005 US$) in Colombia in 1996 to that in 1998?
Offer a terse response. 0.94. What is the ratio of the Value added (constant 2005 US$) of Nigeria in 1996 to that in 1998?
Provide a short and direct response. 0.93. What is the ratio of the Value added (constant 2005 US$) of Cameroon in 1997 to that in 1998?
Your response must be concise. 0.99. What is the ratio of the Value added (constant 2005 US$) in Central African Republic in 1997 to that in 1998?
Keep it short and to the point. 0.93. What is the ratio of the Value added (constant 2005 US$) of Nigeria in 1997 to that in 1998?
Offer a very short reply. 0.96. What is the difference between the highest and the second highest Value added (constant 2005 US$) in Cameroon?
Your answer should be compact. 6.31e+07. What is the difference between the highest and the second highest Value added (constant 2005 US$) in Central African Republic?
Your answer should be compact. 6.71e+06. What is the difference between the highest and the second highest Value added (constant 2005 US$) of Colombia?
Provide a short and direct response. 6.36e+08. What is the difference between the highest and the second highest Value added (constant 2005 US$) in Nigeria?
Offer a very short reply. 5.54e+08. What is the difference between the highest and the lowest Value added (constant 2005 US$) in Cameroon?
Give a very brief answer. 9.51e+08. What is the difference between the highest and the lowest Value added (constant 2005 US$) in Central African Republic?
Provide a short and direct response. 6.74e+07. What is the difference between the highest and the lowest Value added (constant 2005 US$) in Colombia?
Keep it short and to the point. 1.03e+1. What is the difference between the highest and the lowest Value added (constant 2005 US$) of Nigeria?
Offer a very short reply. 1.53e+09. 